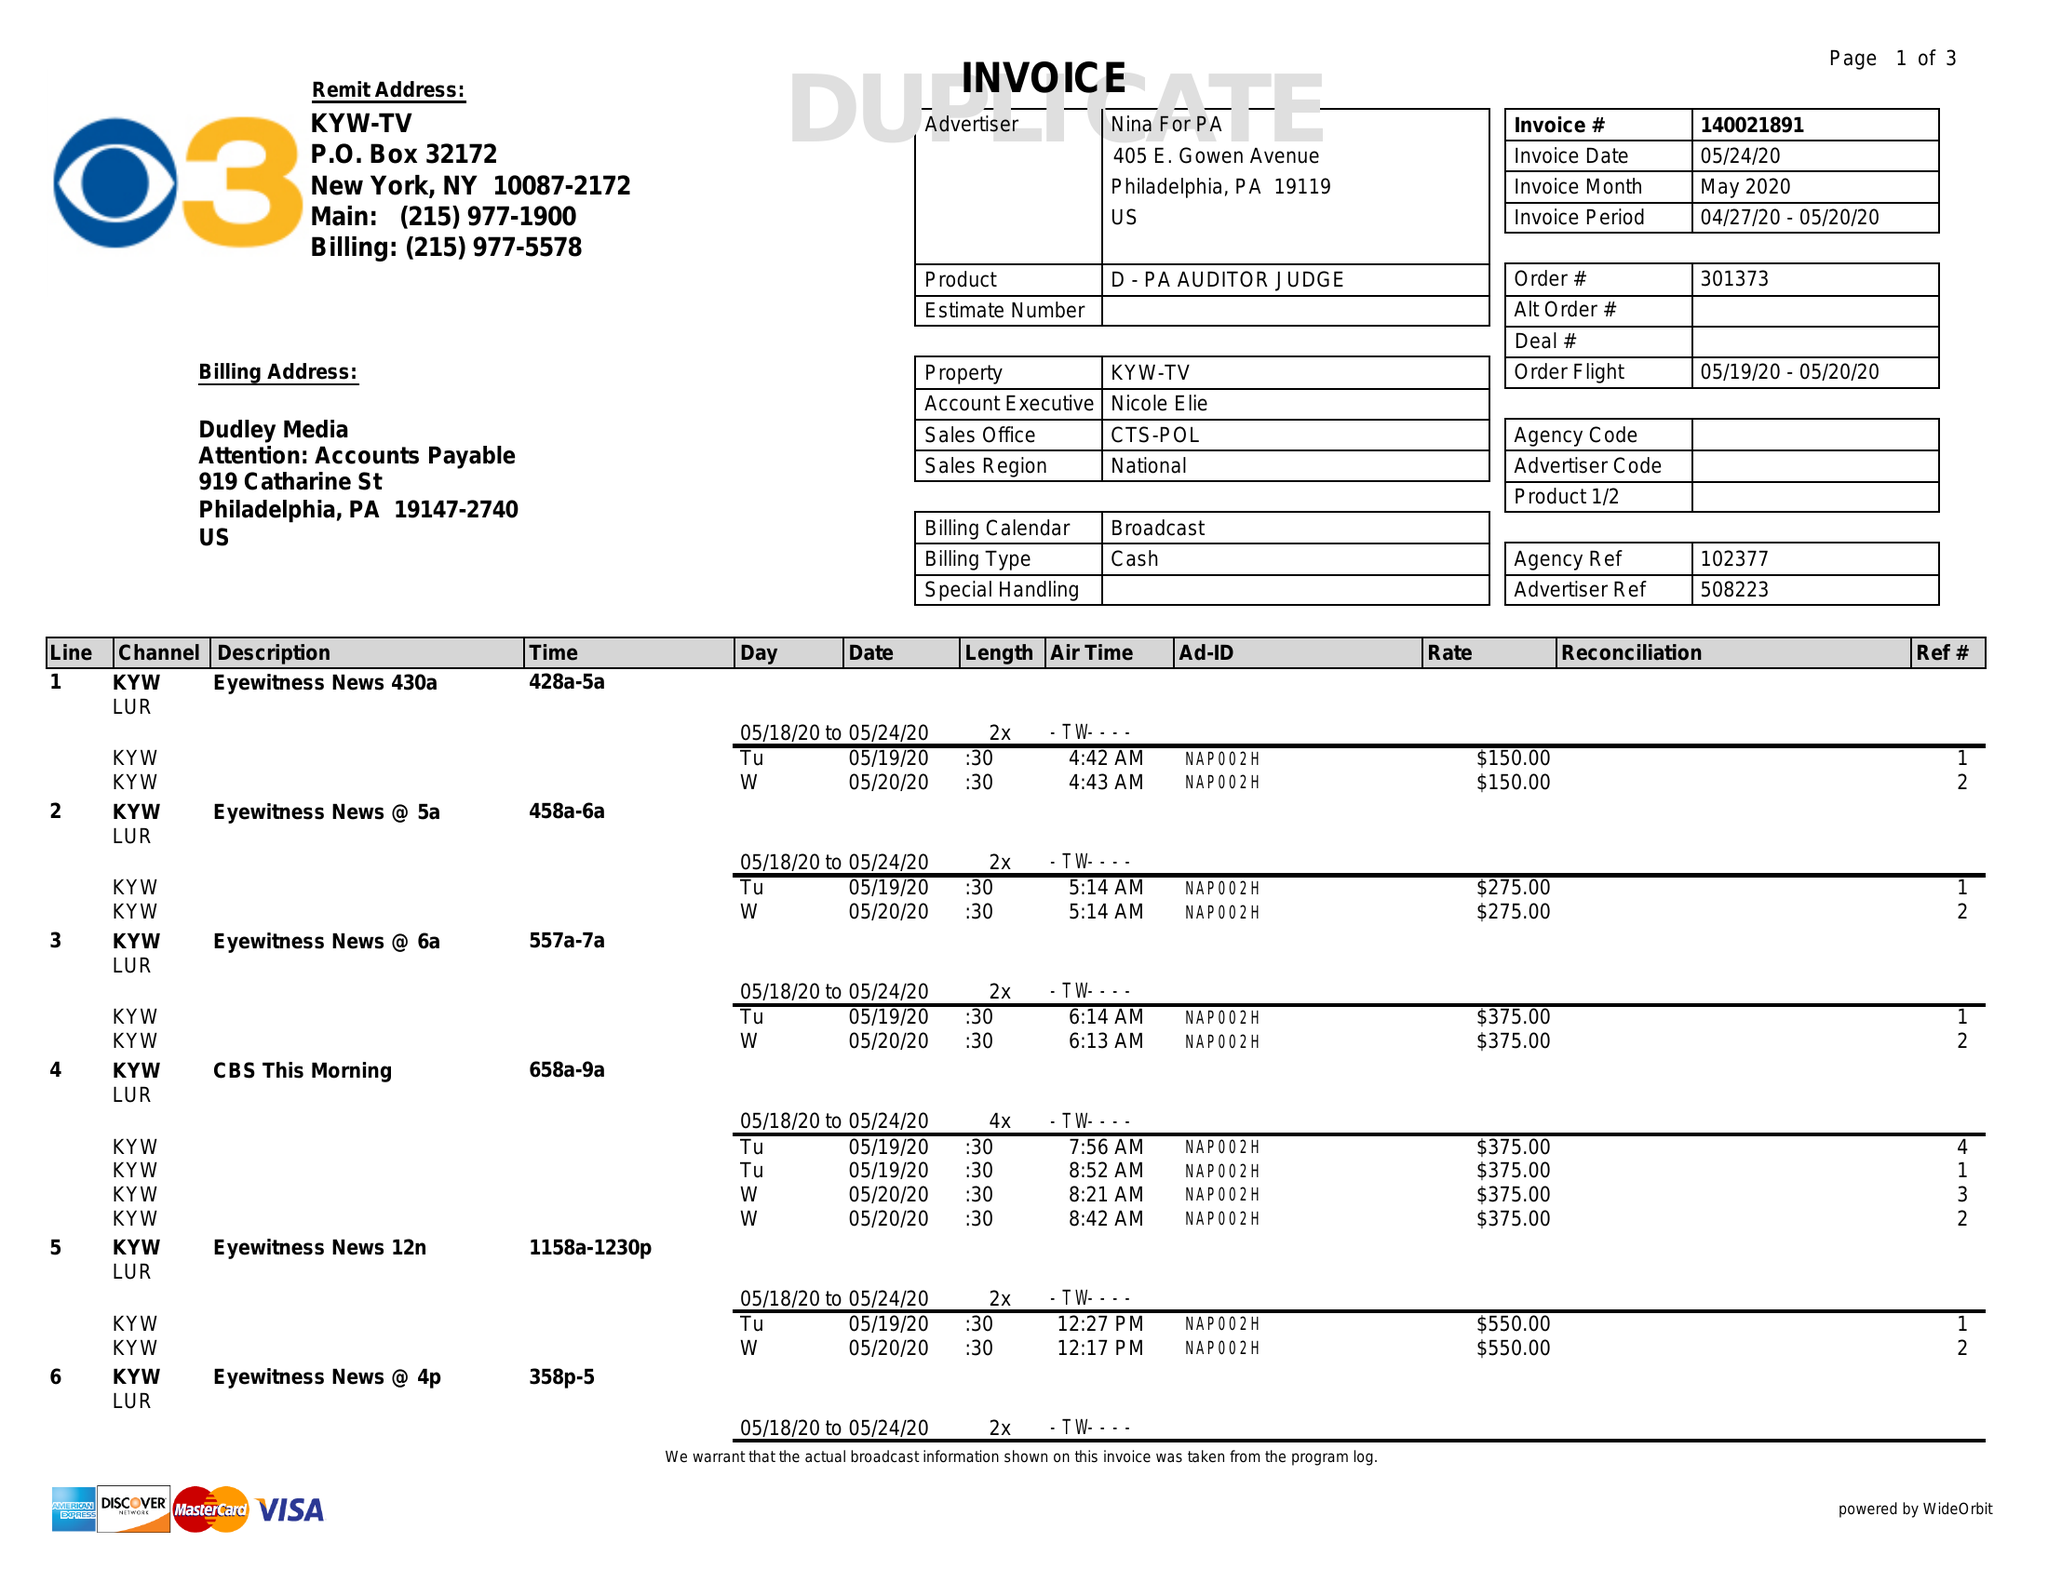What is the value for the contract_num?
Answer the question using a single word or phrase. 140021891 